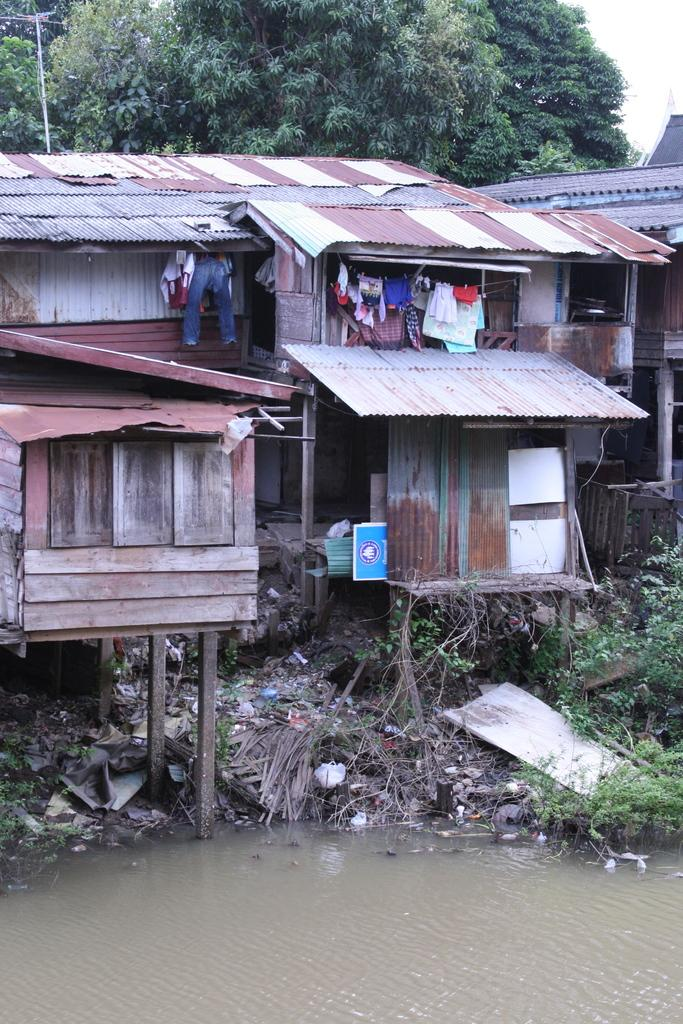What type of structures are present in the image? There are huts in the image. What is located near the huts? There is garbage near the huts. What natural element can be seen in the image? There is water visible in the image. What type of vegetation is behind the huts? There are trees behind the huts. What historical event is depicted in the image? There is no historical event depicted in the image; it shows huts, garbage, water, and trees. What type of mineral can be seen in the image? There is no mineral, such as quartz, present in the image. 